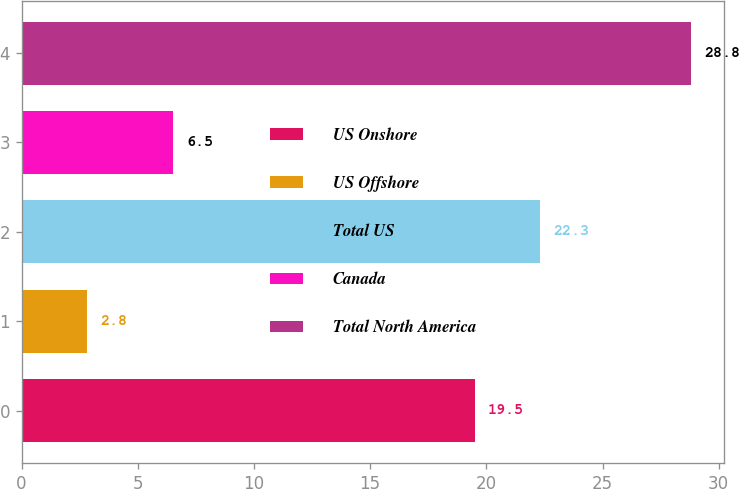Convert chart. <chart><loc_0><loc_0><loc_500><loc_500><bar_chart><fcel>US Onshore<fcel>US Offshore<fcel>Total US<fcel>Canada<fcel>Total North America<nl><fcel>19.5<fcel>2.8<fcel>22.3<fcel>6.5<fcel>28.8<nl></chart> 